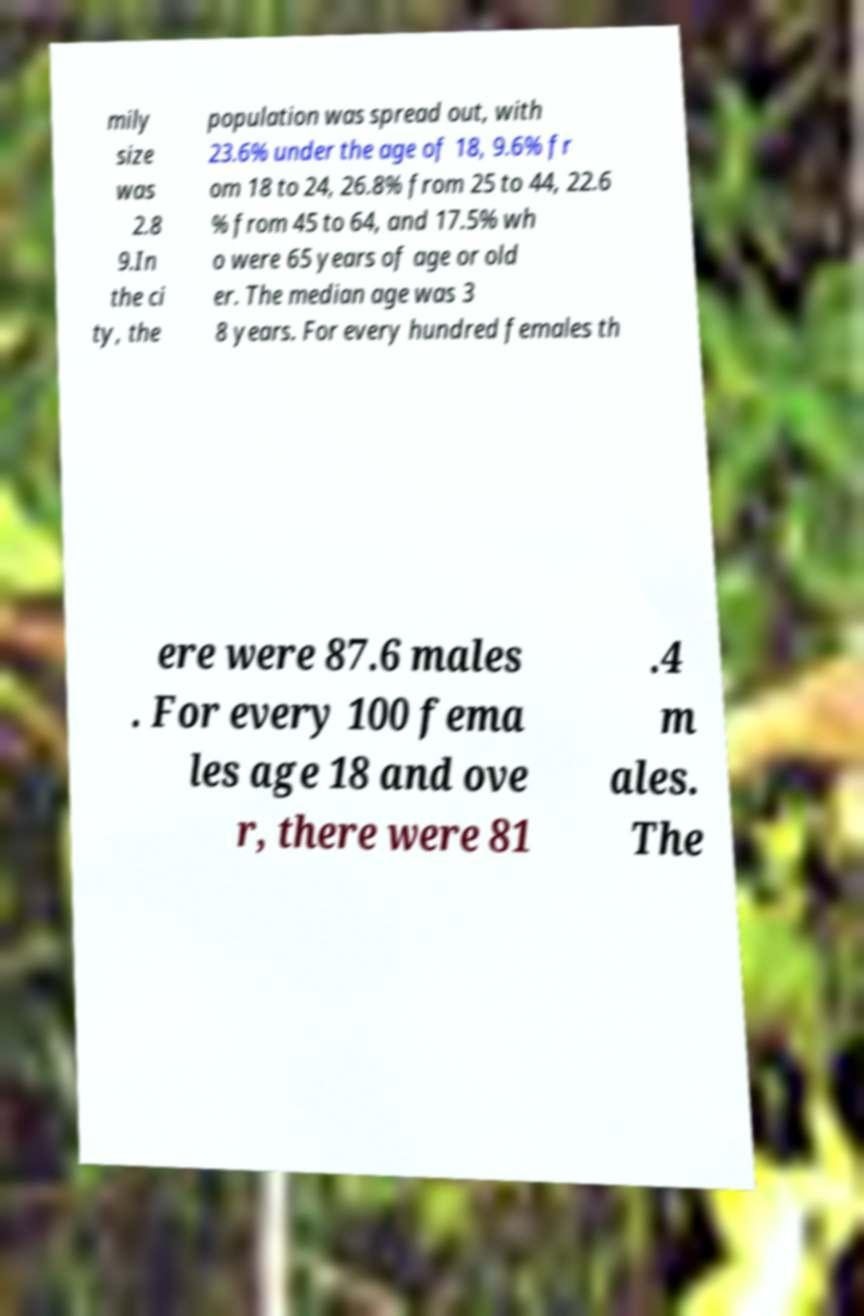Please read and relay the text visible in this image. What does it say? mily size was 2.8 9.In the ci ty, the population was spread out, with 23.6% under the age of 18, 9.6% fr om 18 to 24, 26.8% from 25 to 44, 22.6 % from 45 to 64, and 17.5% wh o were 65 years of age or old er. The median age was 3 8 years. For every hundred females th ere were 87.6 males . For every 100 fema les age 18 and ove r, there were 81 .4 m ales. The 